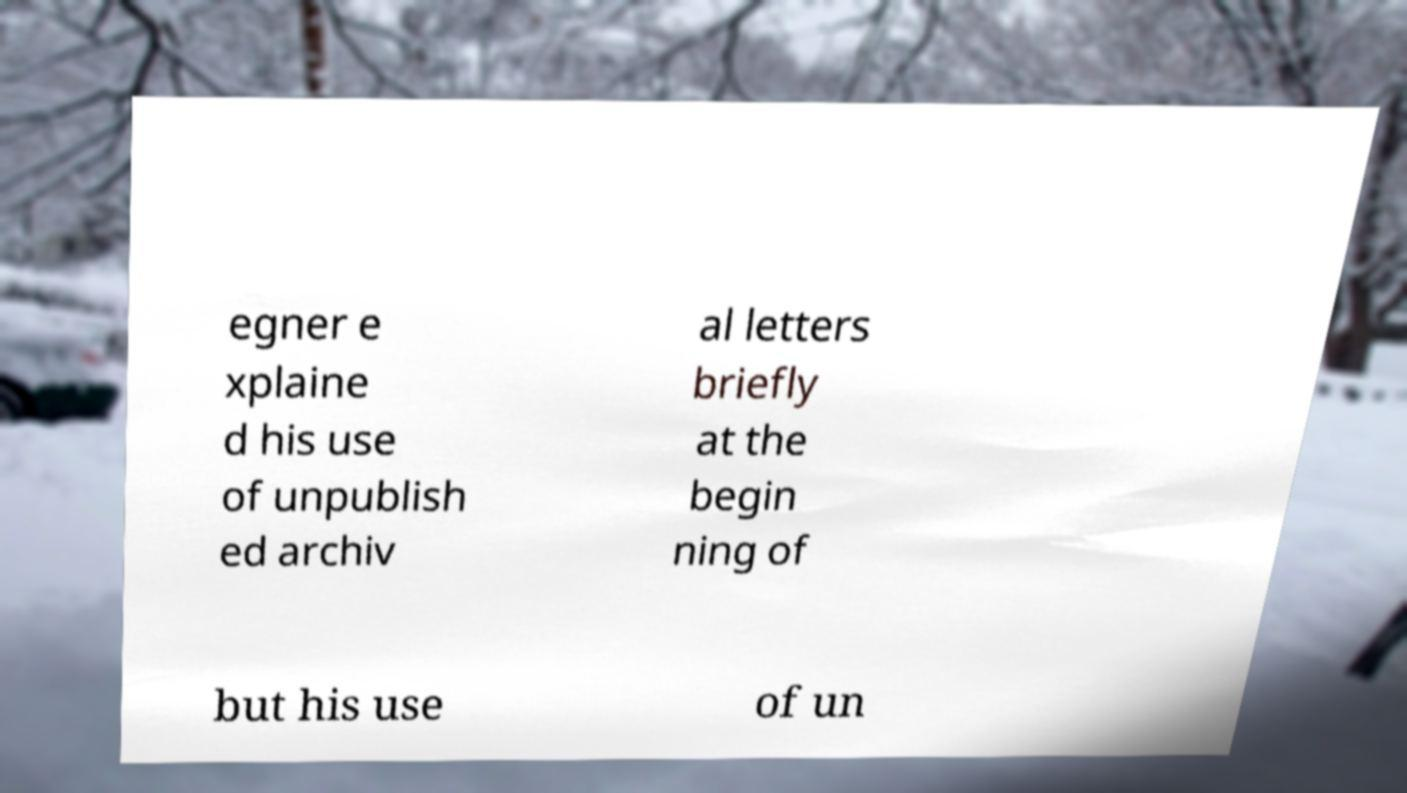What messages or text are displayed in this image? I need them in a readable, typed format. egner e xplaine d his use of unpublish ed archiv al letters briefly at the begin ning of but his use of un 